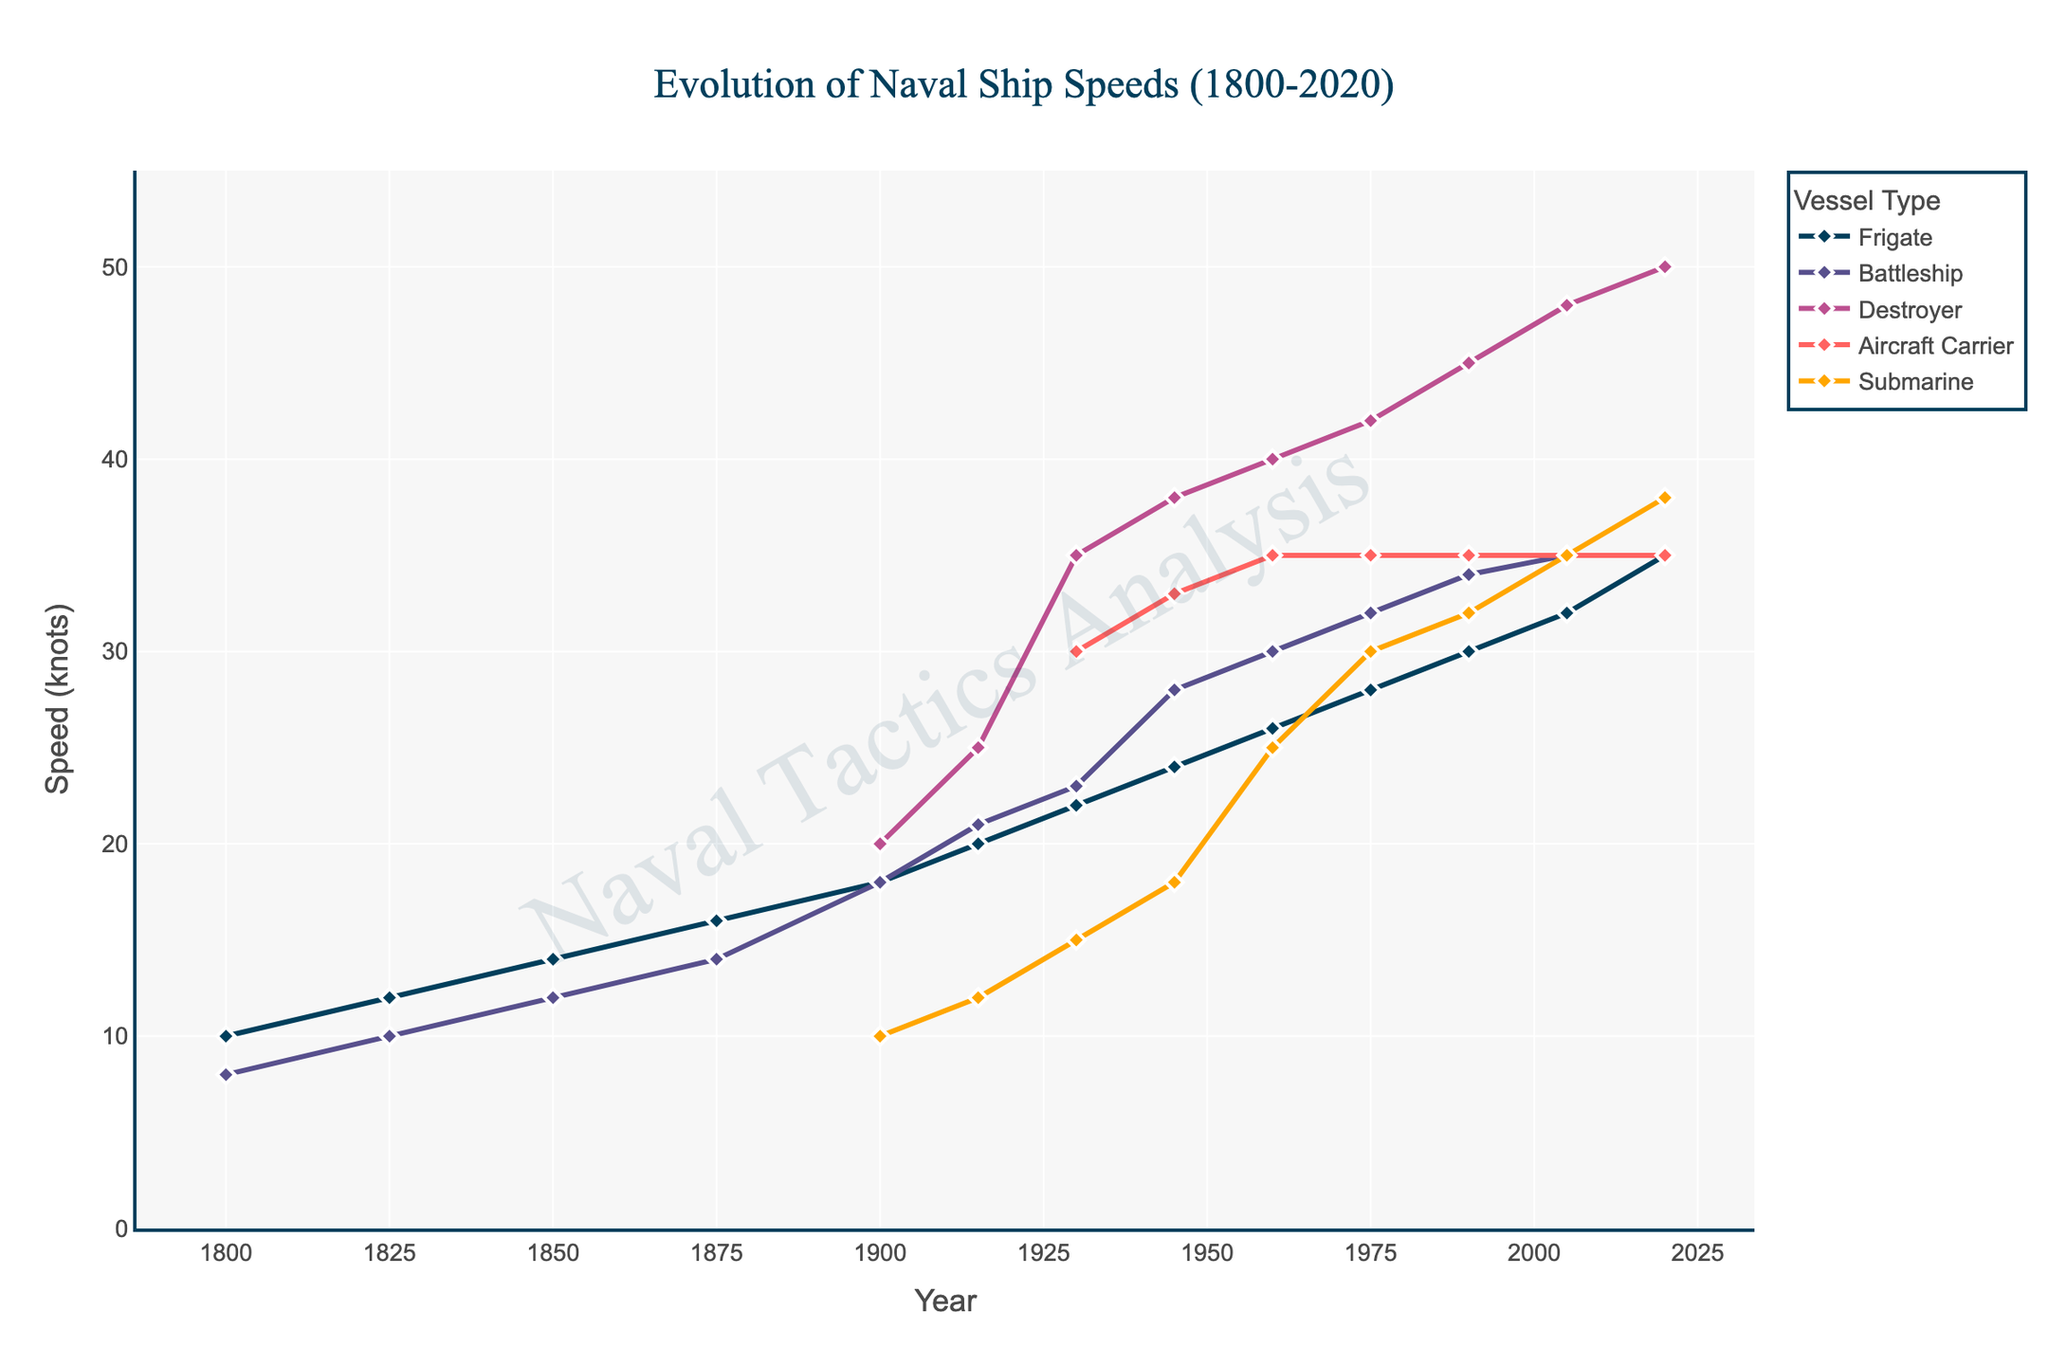what is the speed difference between the fastest destroyer and the fastest aircraft carrier in 2020? The speed of the destroyer in 2020 is 50 knots, and the speed of the aircraft carrier is 35 knots. The difference is 50 - 35 = 15 knots.
Answer: 15 knots Between 1800 and 1900, which class of ship saw the most significant increase in speed? In 1800, the frigate's speed was 10 knots and increased to 18 knots by 1900, showing an 8 knots increase. For battleships, the speed increased from 8 knots to 18 knots, representing a 10 knots increase. Frigates saw an 8 knots increase, so the most significant increase is by battleships.
Answer: Battleships What was the speed of submarines in 1945 and how does it compare to the speed of destroyers at the same year? In 1945, the speed of the submarines was 18 knots, and the speed of the destroyers was 38 knots. Destroyers were 38 - 18 = 20 knots faster than submarines in 1945.
Answer: 20 knots How has the speed of aircraft carriers changed since their introduction in 1930 to 1945? Aircraft carriers were introduced in 1930 with a speed of 30 knots and by 1945 increased to 33 knots. The change in speed is 33 - 30 = 3 knots.
Answer: 3 knots What was the speed of frigates in 1825, and how does this compare to the corresponding year for battleships? In 1825, the speed of frigates was 12 knots and the speed of battleships was 10 knots. The speed difference is 12 - 10 = 2 knots.
Answer: 2 knots During which period did destroyers experience their most rapid acceleration in speed? The destroyers saw the most rapid acceleration in speed between 1915 (25 knots) and 1930 (35 knots), an increase of 35 - 25 = 10 knots in 15 years.
Answer: 1915-1930 What is the combined speed of all vessel types in 1960? In 1960, the speeds are as follows: Frigate = 26, Battleship = 30, Destroyer = 40, Aircraft Carrier = 35, Submarine = 25. The combined speed is 26 + 30 + 40 + 35 + 25 = 156 knots.
Answer: 156 knots 